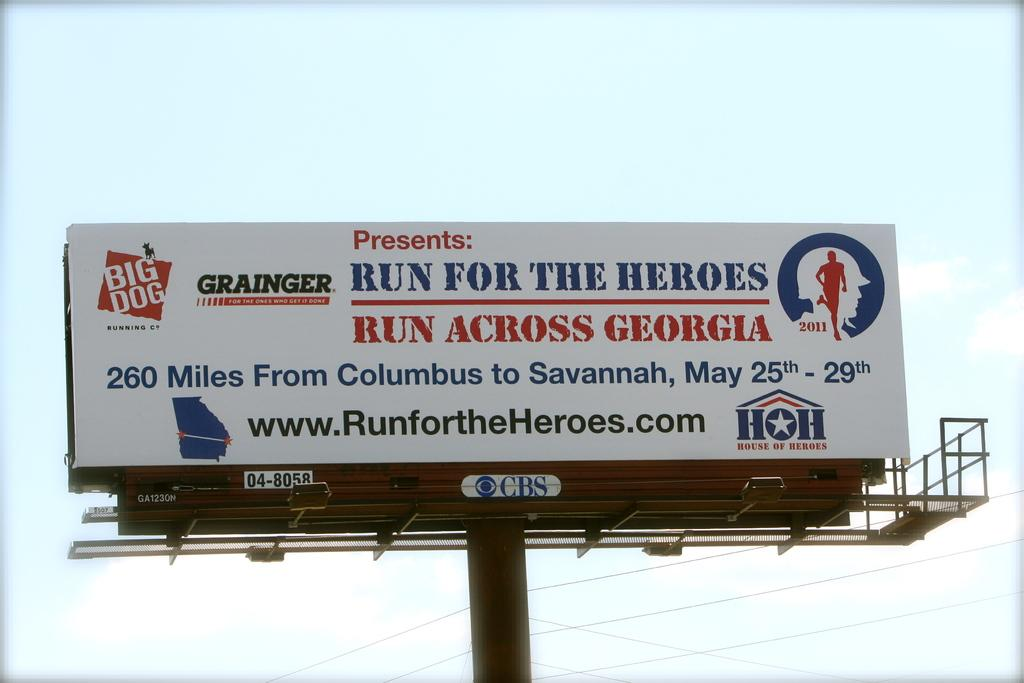<image>
Provide a brief description of the given image. A billboard advertises the Run for the Heroes/Run Across Georgia event. 